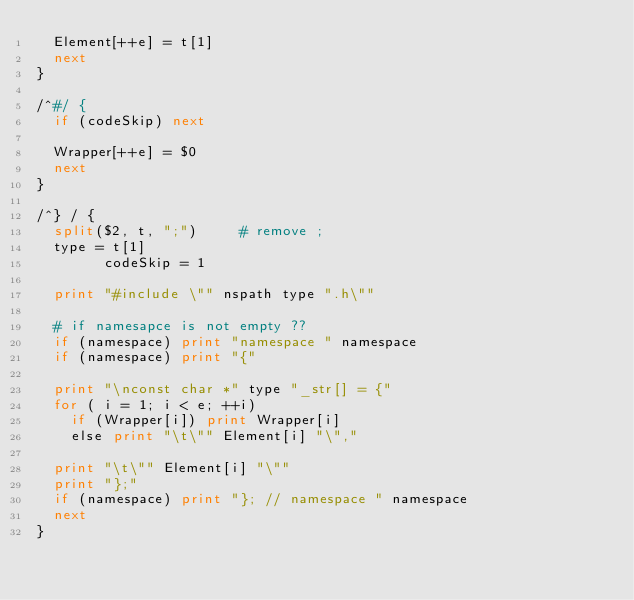<code> <loc_0><loc_0><loc_500><loc_500><_Awk_>	Element[++e] = t[1]
	next
}

/^#/ {
	if (codeSkip) next

	Wrapper[++e] = $0
	next
}

/^} / {
	split($2, t, ";")			# remove ;
	type = t[1]
        codeSkip = 1

	print "#include \"" nspath type ".h\""

	# if namesapce is not empty ??
	if (namespace) print "namespace " namespace
	if (namespace) print "{"

	print "\nconst char *" type "_str[] = {"
	for ( i = 1; i < e; ++i)
		if (Wrapper[i]) print Wrapper[i]
		else print "\t\"" Element[i] "\","

	print "\t\"" Element[i] "\""
	print "};"
	if (namespace) print "}; // namespace " namespace
	next
}
</code> 